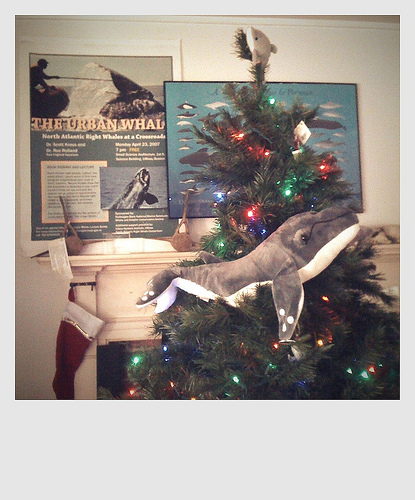<image>
Can you confirm if the stuffed whale is on the stocking? No. The stuffed whale is not positioned on the stocking. They may be near each other, but the stuffed whale is not supported by or resting on top of the stocking. 